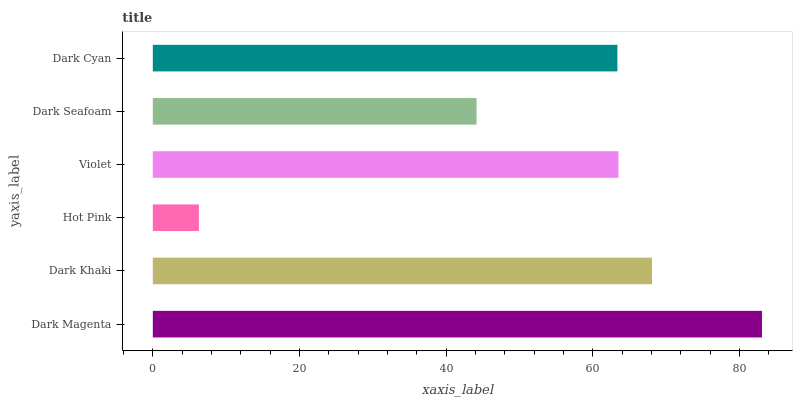Is Hot Pink the minimum?
Answer yes or no. Yes. Is Dark Magenta the maximum?
Answer yes or no. Yes. Is Dark Khaki the minimum?
Answer yes or no. No. Is Dark Khaki the maximum?
Answer yes or no. No. Is Dark Magenta greater than Dark Khaki?
Answer yes or no. Yes. Is Dark Khaki less than Dark Magenta?
Answer yes or no. Yes. Is Dark Khaki greater than Dark Magenta?
Answer yes or no. No. Is Dark Magenta less than Dark Khaki?
Answer yes or no. No. Is Violet the high median?
Answer yes or no. Yes. Is Dark Cyan the low median?
Answer yes or no. Yes. Is Hot Pink the high median?
Answer yes or no. No. Is Violet the low median?
Answer yes or no. No. 